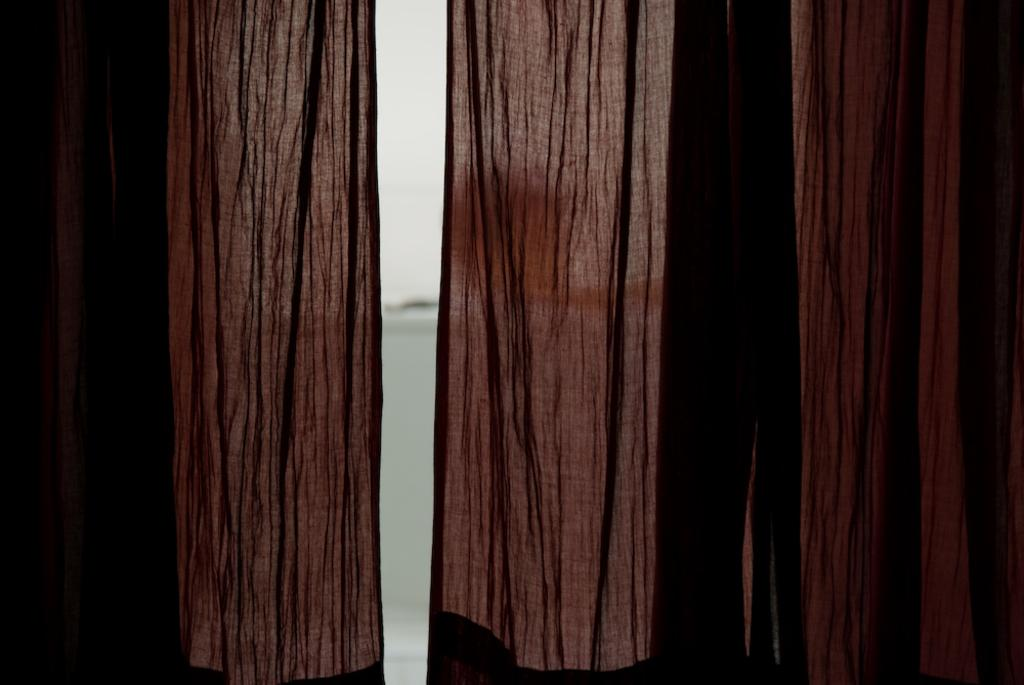What type of window treatment is present in the image? There are curtains in the image. What can be seen through the curtains? Water and the sky are visible behind the curtains. How many collars can be seen on the flock of sheep on the hill in the image? There is no flock of sheep or hill present in the image; it only features curtains, water, and the sky. 